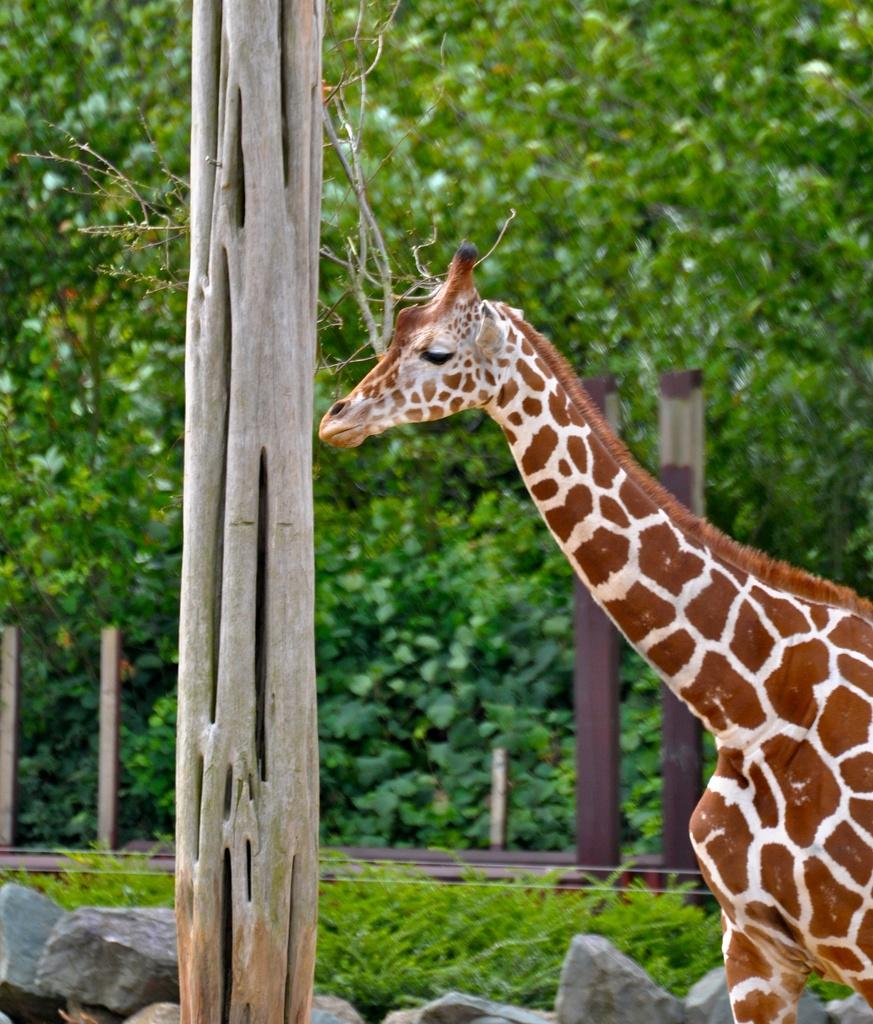What animal is present in the image? There is a giraffe in the image. What is in front of the giraffe? There is a tree trunk in front of the giraffe. What can be found on the surface in the image? There are rocks and plants on the surface in the image. What is visible in the background of the image? There are trees in the background of the image. Can you tell me what the giraffe is wishing for in the image? There is no indication in the image that the giraffe is wishing for anything, as animals do not have the ability to express wishes in the same way humans do. 